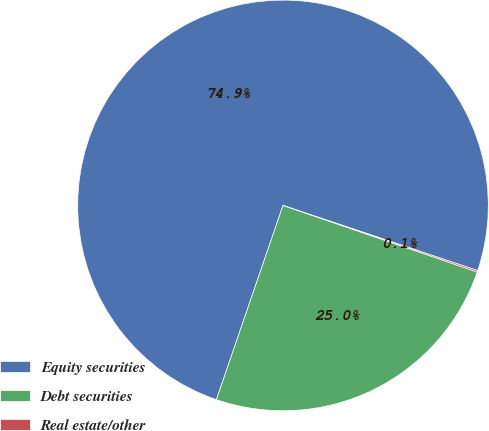Convert chart to OTSL. <chart><loc_0><loc_0><loc_500><loc_500><pie_chart><fcel>Equity securities<fcel>Debt securities<fcel>Real estate/other<nl><fcel>74.88%<fcel>25.0%<fcel>0.12%<nl></chart> 